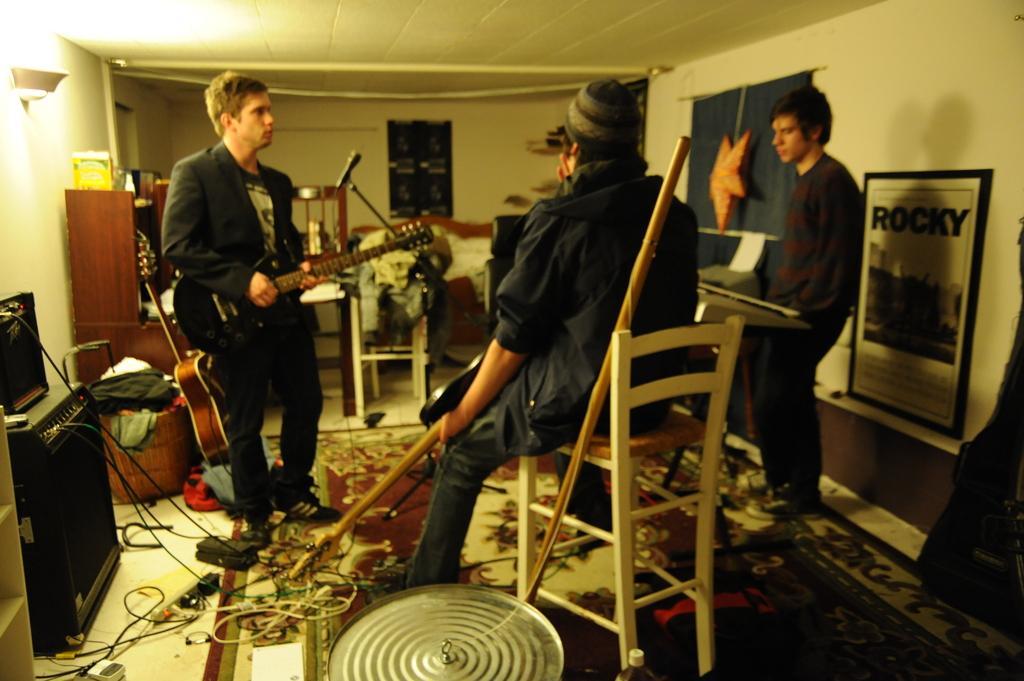In one or two sentences, can you explain what this image depicts? In this picture there are three men. The men in the left side is wearing a jacket and playing a guitar. The men in the middle is sitting on the chair and holding a guitar. The man at the right side is standing in front of the piano. Behind him there is a poster. And to the left side there is a monitor and a speaker. In the background there are some clothes, curtains, star. In the bottom there are some wires and a floor mat. 